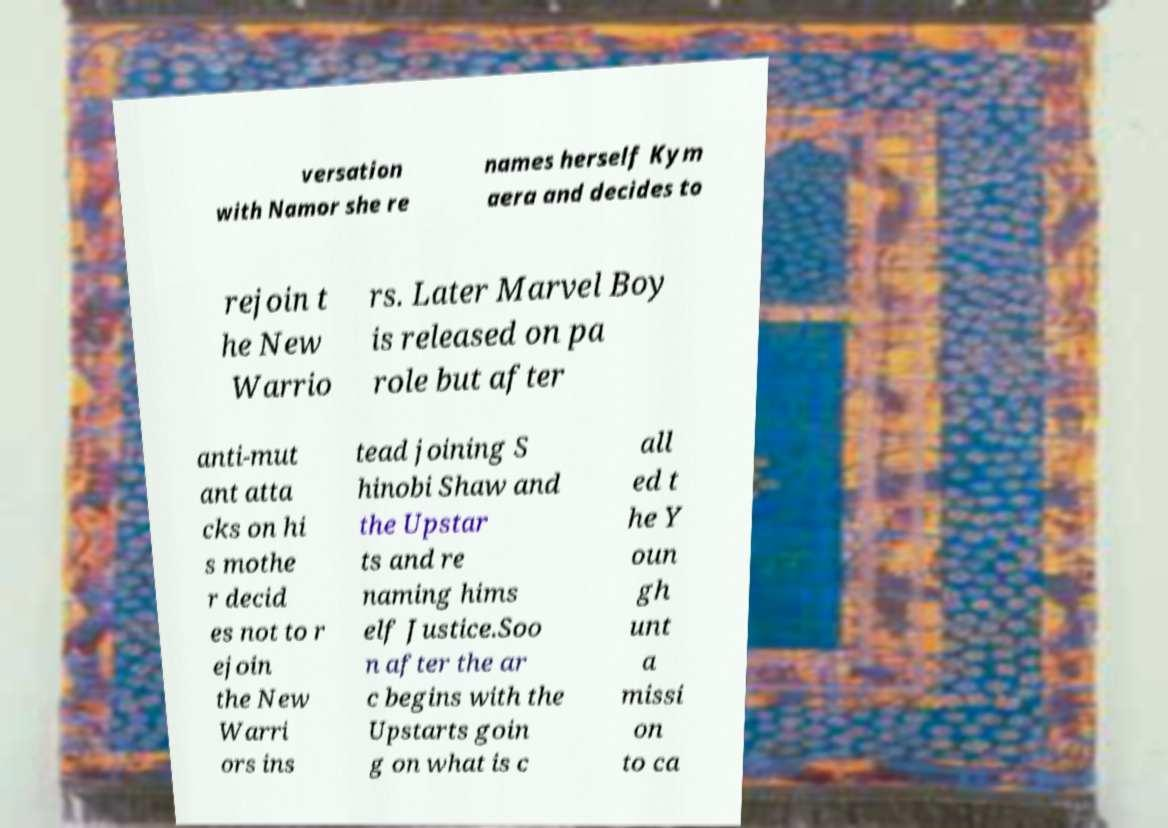Can you read and provide the text displayed in the image?This photo seems to have some interesting text. Can you extract and type it out for me? versation with Namor she re names herself Kym aera and decides to rejoin t he New Warrio rs. Later Marvel Boy is released on pa role but after anti-mut ant atta cks on hi s mothe r decid es not to r ejoin the New Warri ors ins tead joining S hinobi Shaw and the Upstar ts and re naming hims elf Justice.Soo n after the ar c begins with the Upstarts goin g on what is c all ed t he Y oun gh unt a missi on to ca 